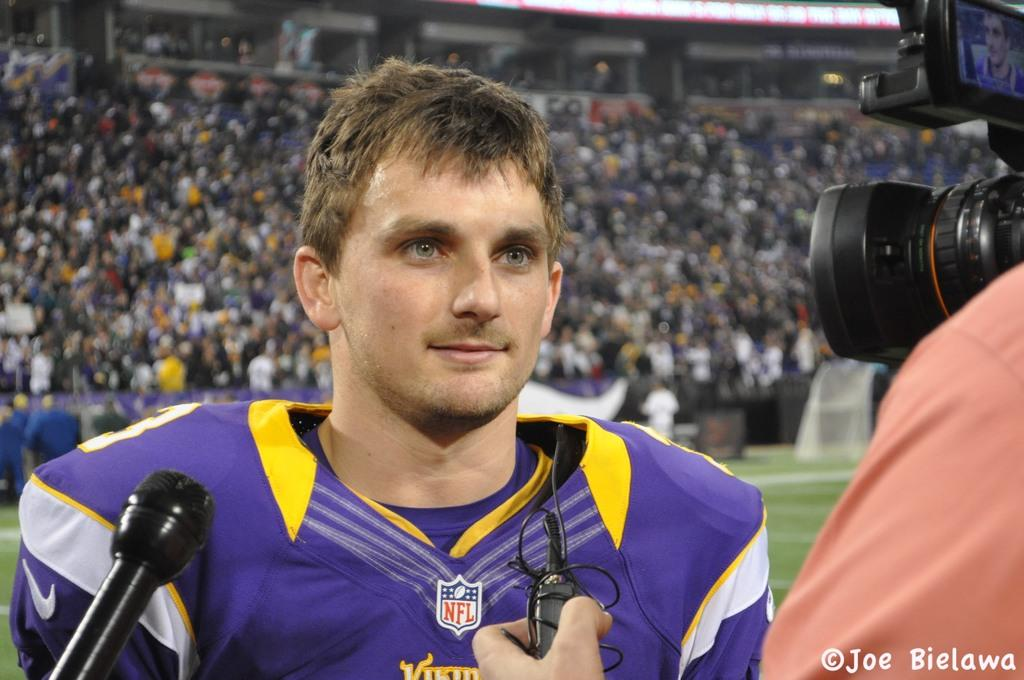<image>
Summarize the visual content of the image. The man being interviewed is a player from the NFL. 